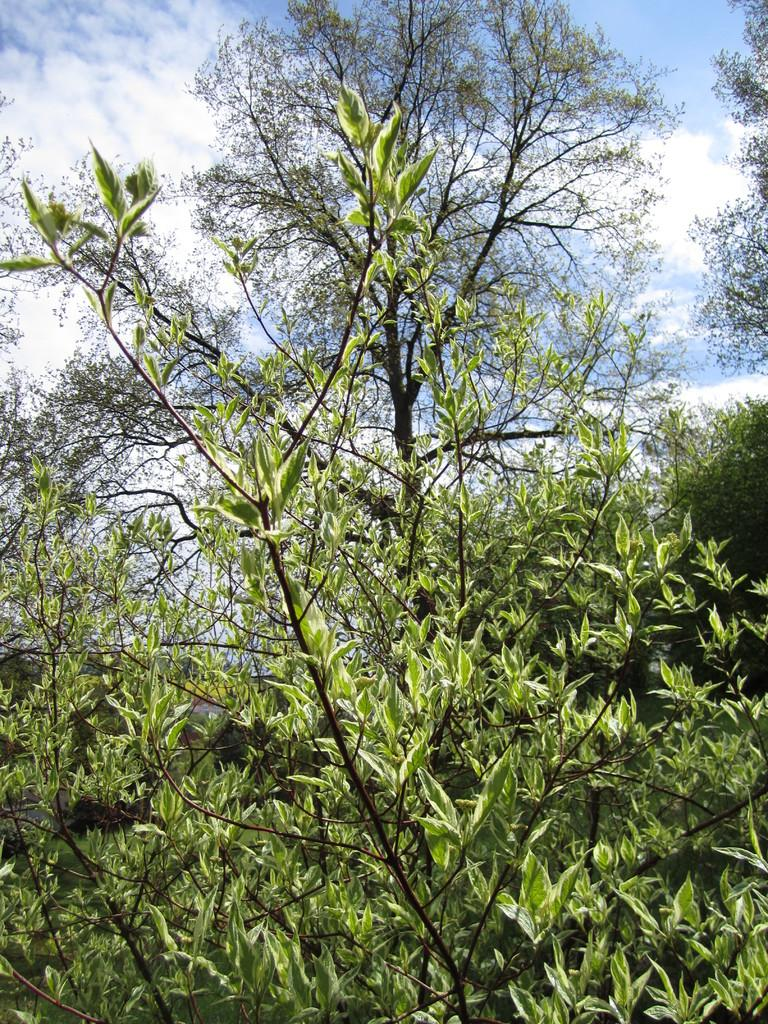What type of vegetation can be seen in the image? There are branches and leaves in the image. What is visible in the background of the image? There is sky visible in the background of the image. What can be seen in the sky in the image? Clouds are present in the sky. What direction is the cable running in the image? There is no cable present in the image. What type of toothpaste is being used to clean the leaves in the image? There is no toothpaste or cleaning activity involving leaves in the image. 